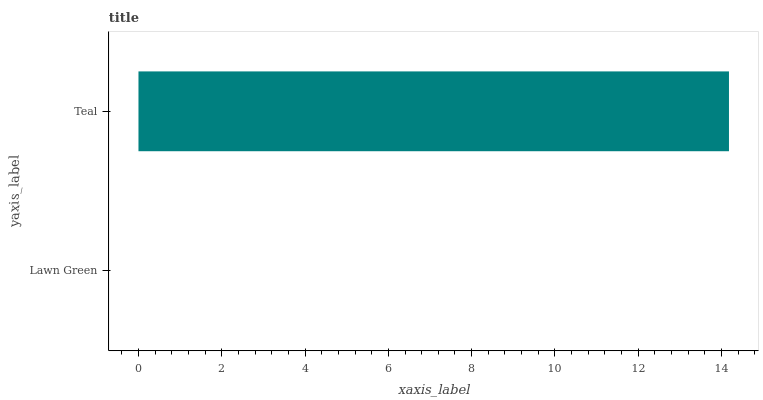Is Lawn Green the minimum?
Answer yes or no. Yes. Is Teal the maximum?
Answer yes or no. Yes. Is Teal the minimum?
Answer yes or no. No. Is Teal greater than Lawn Green?
Answer yes or no. Yes. Is Lawn Green less than Teal?
Answer yes or no. Yes. Is Lawn Green greater than Teal?
Answer yes or no. No. Is Teal less than Lawn Green?
Answer yes or no. No. Is Teal the high median?
Answer yes or no. Yes. Is Lawn Green the low median?
Answer yes or no. Yes. Is Lawn Green the high median?
Answer yes or no. No. Is Teal the low median?
Answer yes or no. No. 